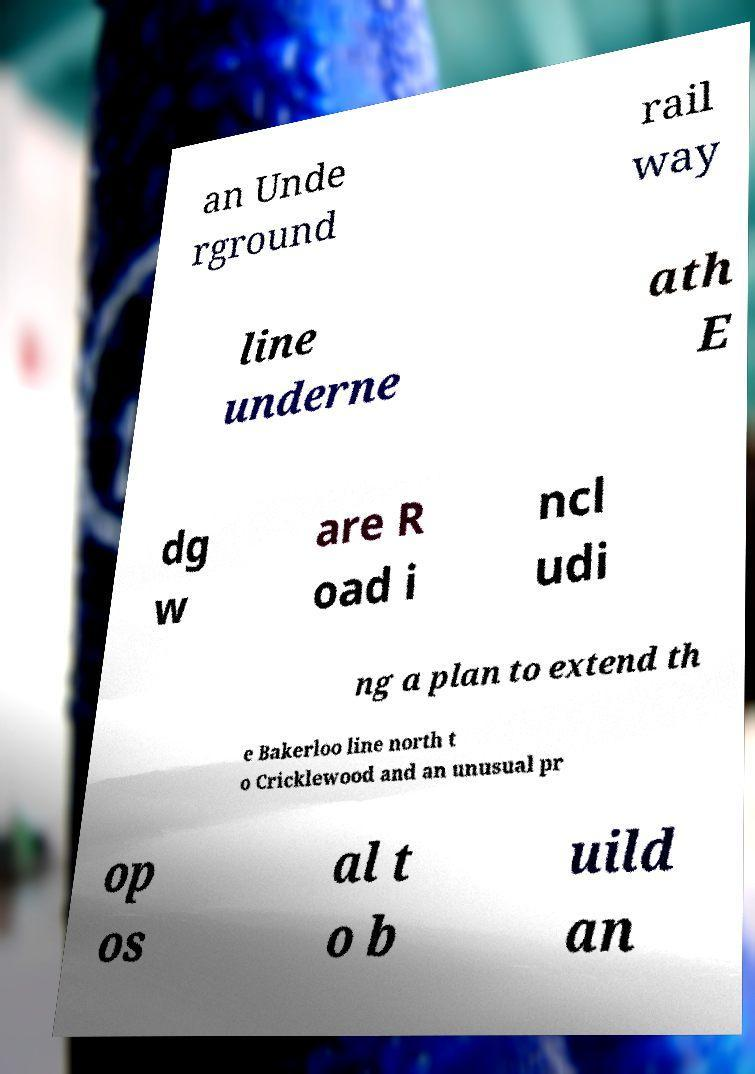There's text embedded in this image that I need extracted. Can you transcribe it verbatim? an Unde rground rail way line underne ath E dg w are R oad i ncl udi ng a plan to extend th e Bakerloo line north t o Cricklewood and an unusual pr op os al t o b uild an 